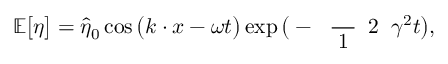<formula> <loc_0><loc_0><loc_500><loc_500>\mathbb { E } \left [ \eta \right ] = \widehat { \eta } _ { 0 } \cos \left ( k \cdot x - \omega t \right ) \exp \left ( - \frac { 1 } { 2 } \gamma ^ { 2 } t \right ) ,</formula> 